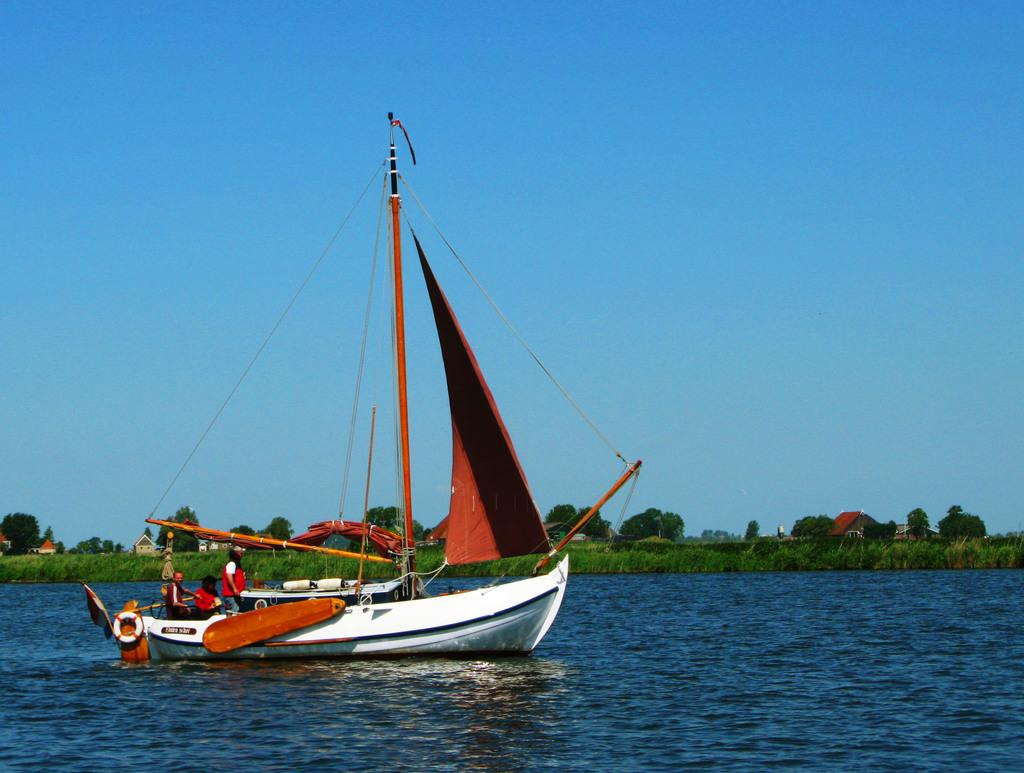What is the main subject of the image? The main subject of the image is a boat. How many people are in the boat? There are three people in the boat. What is the purpose of the swim tube on the boat? The swim tube on the boat is likely for safety or recreational purposes. What else can be seen on the boat? There are other objects on the boat. What is the setting of the image? The image features water, plants, trees, houses, and the sky, suggesting it is a waterfront or lakeside location. What type of hat is the vein wearing in the image? There is no vein or hat present in the image; it features a boat with people and objects on it. 